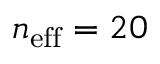Convert formula to latex. <formula><loc_0><loc_0><loc_500><loc_500>n _ { e f f } = 2 0</formula> 